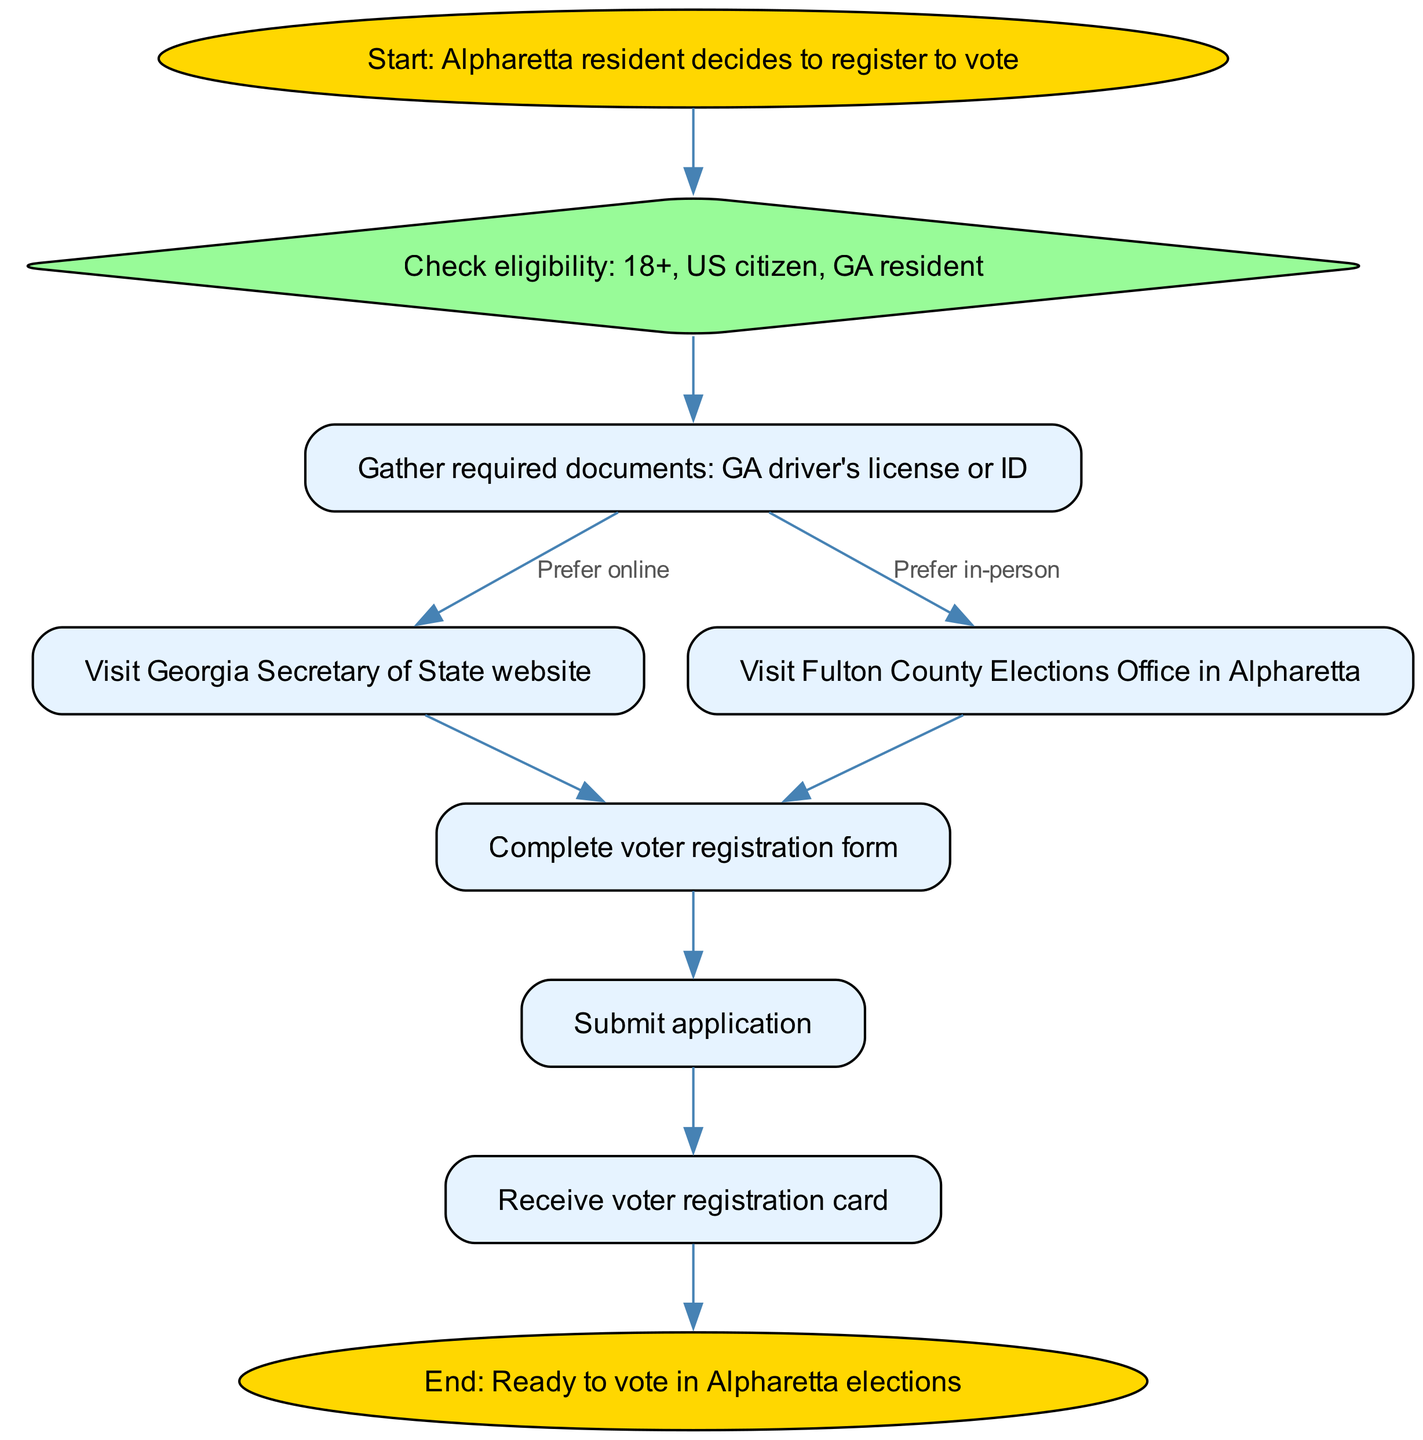What is the first step in the voter registration process? The first step is indicated as the "Start" node, which states that an Alpharetta resident decides to register to vote. This node marks the beginning of the process flow.
Answer: Start: Alpharetta resident decides to register to vote How many total nodes are in this diagram? By counting all the distinct nodes listed in the data under "nodes", we see that there are ten nodes, which include all steps from start to end.
Answer: 10 What step follows after checking eligibility? After the "Check eligibility" step, the next step specified in the diagram is "Gather required documents". This shows a sequential flow where eligibility leads to gathering necessary documents.
Answer: Gather required documents: GA driver's license or ID How can a resident prefer to register after gathering documents? According to the edge connections, after gathering documents, the resident can prefer either "online registration" or "in-person registration." This provides two possible pathways depending on the resident's choice.
Answer: Online registration or In-person registration What happens after submitting the application? The diagram specifies that once the application is submitted, the next node to receive is "Receive voter registration card". This indicates the confirmation process follows submission.
Answer: Receive voter registration card What must a resident do before visiting the Secretary of State website? Before visiting the Georgia Secretary of State website for online registration, the resident must gather required documents as indicated in the flowchart. This clarification informs the order of tasks necessary for registration.
Answer: Gather required documents: GA driver's license or ID Exactly how many edges are in the diagram? By counting the connections made between the nodes as described in the "edges" data, there are a total of nine edges showing the flow from one step to another in the voter registration process.
Answer: 9 What is the purpose of the diamond-shaped node in the diagram? The diamond-shaped node indicates a decision point where residents must check their eligibility. This shape is typically used in flowcharts to represent choices or conditions that must be evaluated before proceeding.
Answer: Check eligibility: 18+, US citizen, GA resident What indicates that a task is completed in the flowchart? In this flowchart, reaching the "Receive voter registration card" node indicates that the task of voter registration has been completed successfully after submitting the application. This node signifies the end of the process chain.
Answer: Receive voter registration card 